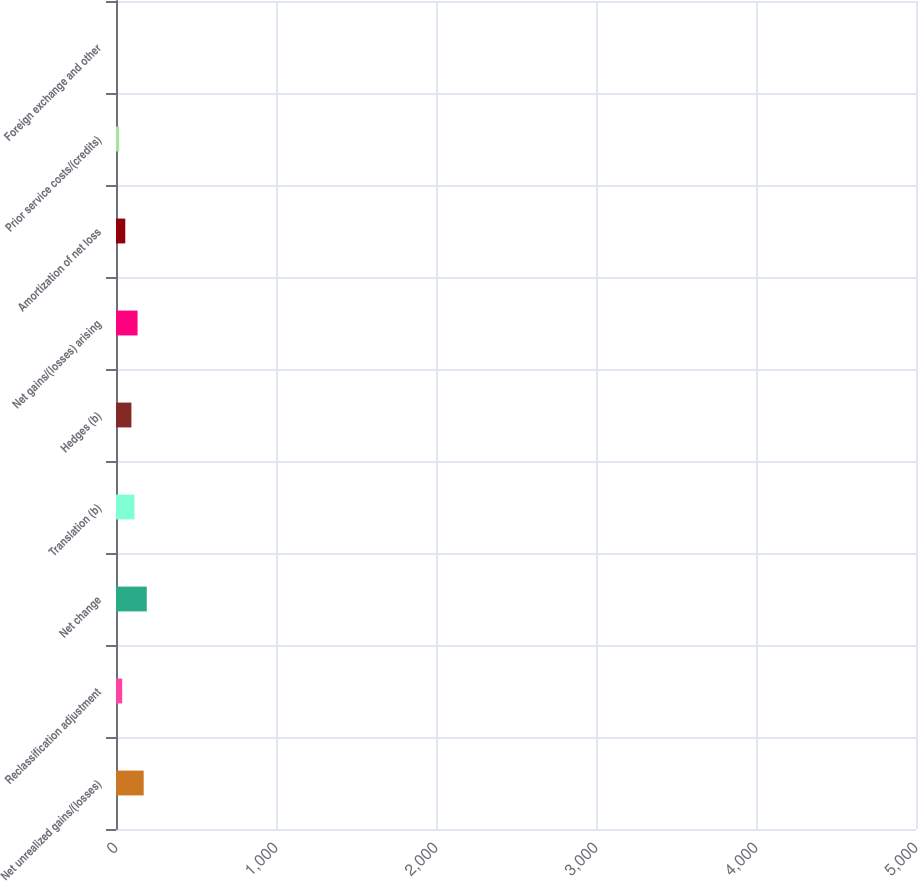Convert chart to OTSL. <chart><loc_0><loc_0><loc_500><loc_500><bar_chart><fcel>Net unrealized gains/(losses)<fcel>Reclassification adjustment<fcel>Net change<fcel>Translation (b)<fcel>Hedges (b)<fcel>Net gains/(losses) arising<fcel>Amortization of net loss<fcel>Prior service costs/(credits)<fcel>Foreign exchange and other<nl><fcel>3664<fcel>821.2<fcel>4070.1<fcel>2445.6<fcel>2039.5<fcel>2851.7<fcel>1227.3<fcel>415.1<fcel>9<nl></chart> 